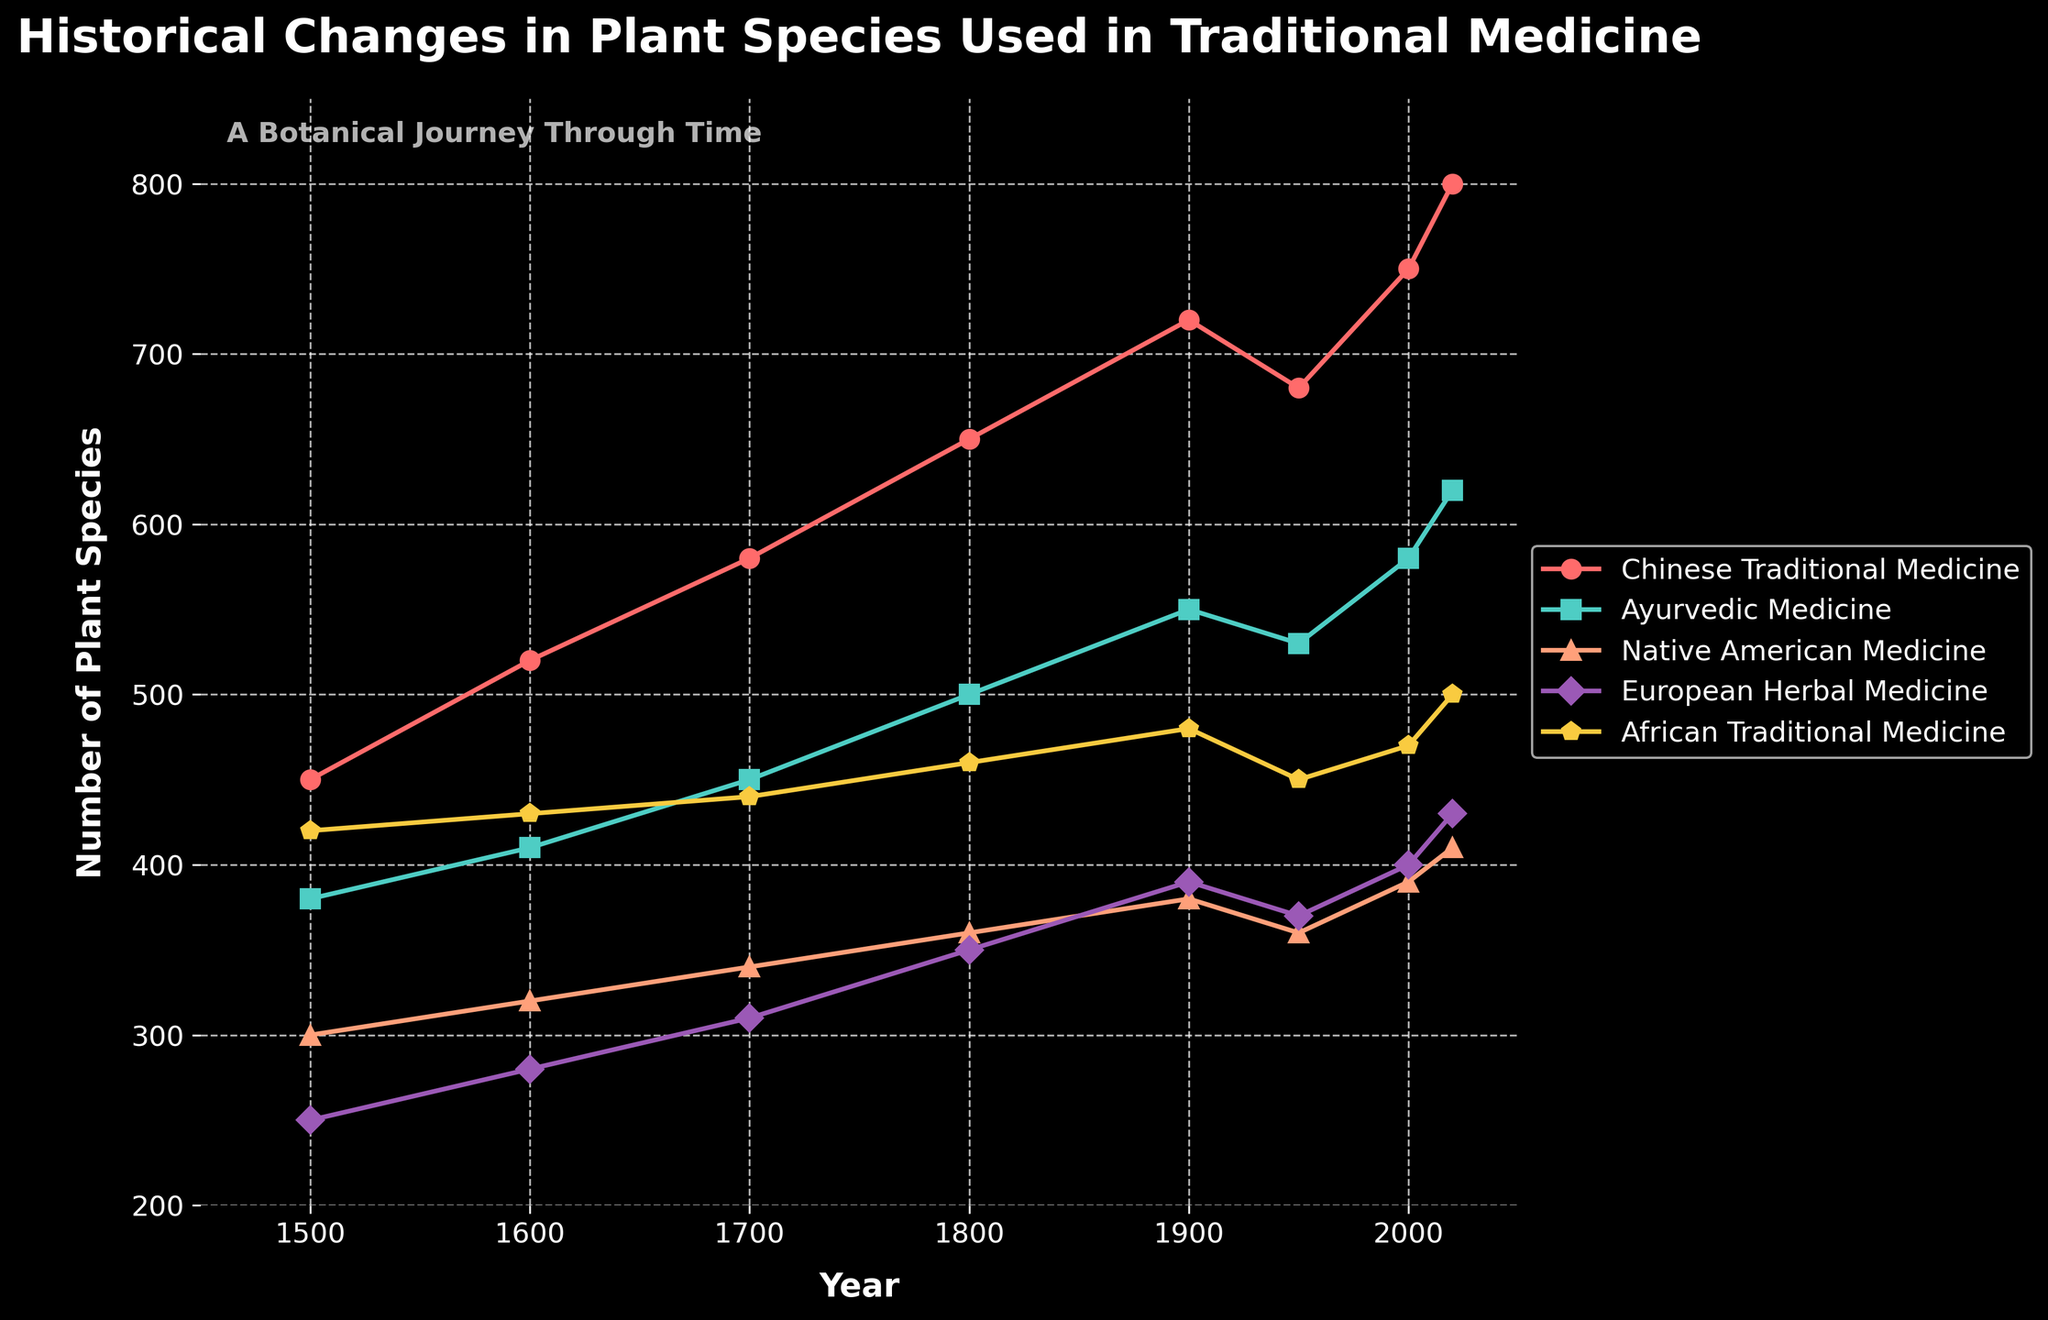What is the trend of plant species used in Chinese Traditional Medicine from 1500 to 2020? The line for Chinese Traditional Medicine shows a general upward trend from 450 in 1500 to 800 in 2020. There is a slight dip around 1950 but overall, the count increases steadily across the centuries.
Answer: Upward trend Which culture has the highest number of plant species used in traditional medicine in 2020? In 2020, the line for Chinese Traditional Medicine reaches the highest point at 800 plant species, which is higher than any other culture noted in the chart.
Answer: Chinese Traditional Medicine Between which two years did European Herbal Medicine see the most significant increase in the number of plant species used? Observing the European Herbal Medicine line, the most significant increase is from 1800 to 1900 where the number jumps from 350 to 390, an increase of 40 species.
Answer: 1800 to 1900 Compare the number of plant species used in Ayurvedic Medicine and African Traditional Medicine in the year 1700. Which is higher and by how much? In 1700, Ayurvedic Medicine has 450 plant species, while African Traditional Medicine has 440 species. Ayurvedic Medicine has 10 more species than African Traditional Medicine.
Answer: Ayurvedic Medicine by 10 species Calculate the average number of plant species used in Native American Medicine across all recorded years. Summing the values for Native American Medicine (300 + 320 + 340 + 360 + 380 + 360 + 390 + 410) gives 2860. Dividing by the 8 recorded years, the average is 2860/8 = 357.5.
Answer: 357.5 Which culture’s traditional medicine shows the least fluctuation in the number of plant species used over time? By observing the smoothness and evenness of the lines, African Traditional Medicine shows the least fluctuation, with relatively small changes over time compared to other cultures.
Answer: African Traditional Medicine How many more plant species were used in Chinese Traditional Medicine compared to European Herbal Medicine in the year 2000? In 2000, Chinese Traditional Medicine had 750 plant species, while European Herbal Medicine had 400 species. The difference is 750 - 400 = 350 species.
Answer: 350 species Identify the years where the number of plant species used in Ayurvedic Medicine was greater than in Native American Medicine. Comparing the lines for Ayurvedic Medicine and Native American Medicine, Ayurvedic Medicine is higher in all years except 1500.
Answer: 1600, 1700, 1800, 1900, 1950, 2000, 2020 In which time period (1500-1600, 1600-1700, etc.) did African Traditional Medicine show the least growth in the number of plant species used? The least growth for African Traditional Medicine was between 1500 (420 species) and 1600 (430 species), showing an increase of only 10 species.
Answer: 1500-1600 Which culture shows a noticeable decline in the number of plant species used around 1950, and did it recover by 2020? Both Chinese Traditional Medicine and Ayurvedic Medicine show a decline around 1950. By 2020, Chinese Traditional Medicine recovers to 800 species, and Ayurvedic Medicine recovers to 620 species.
Answer: Chinese Traditional Medicine and Ayurvedic Medicine, both recovered 